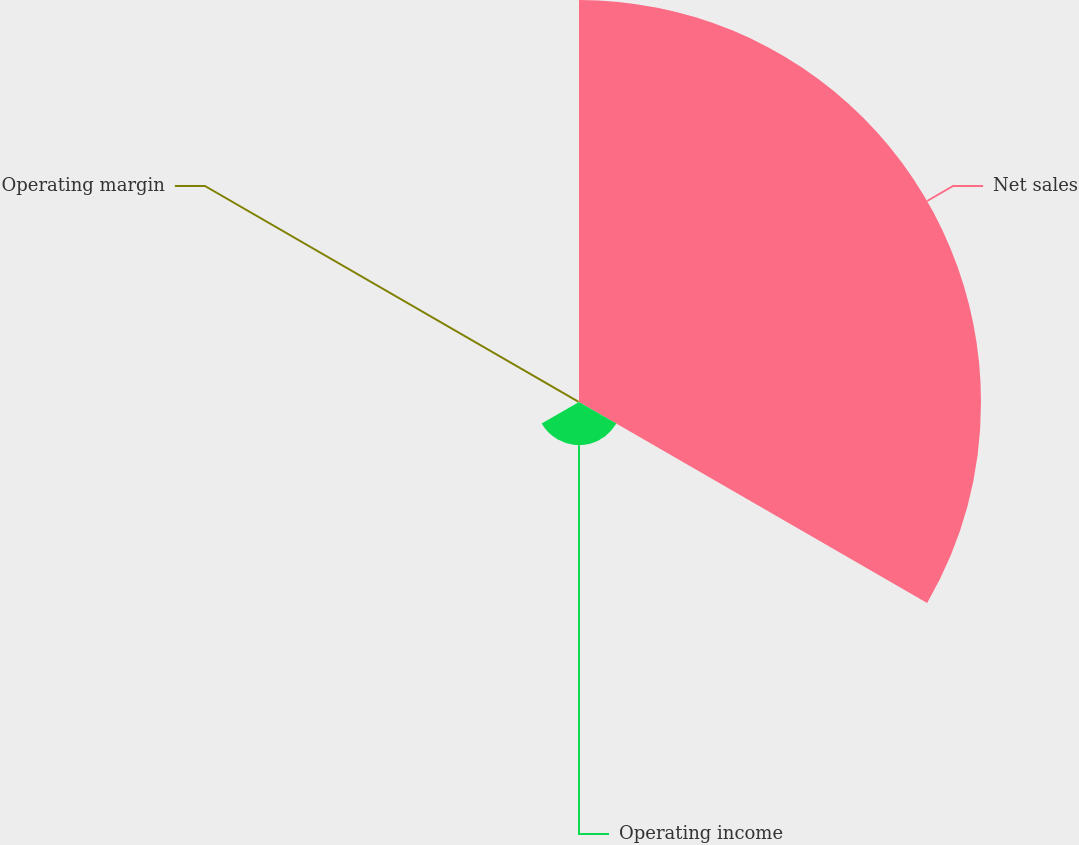Convert chart. <chart><loc_0><loc_0><loc_500><loc_500><pie_chart><fcel>Net sales<fcel>Operating income<fcel>Operating margin<nl><fcel>90.13%<fcel>9.67%<fcel>0.2%<nl></chart> 